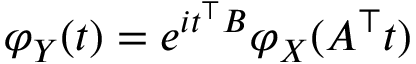Convert formula to latex. <formula><loc_0><loc_0><loc_500><loc_500>\varphi _ { Y } ( t ) = e ^ { i t ^ { \top } B } \varphi _ { X } ( A ^ { \top } t )</formula> 